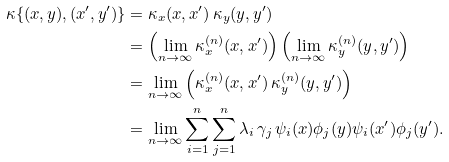Convert formula to latex. <formula><loc_0><loc_0><loc_500><loc_500>\kappa \{ ( x , y ) , ( x ^ { \prime } , y ^ { \prime } ) \} & = \kappa _ { x } ( x , x ^ { \prime } ) \, \kappa _ { y } ( y , y ^ { \prime } ) \\ & = \left ( \lim _ { n \to \infty } \kappa _ { x } ^ { ( n ) } ( x , x ^ { \prime } ) \right ) \left ( \lim _ { n \to \infty } \kappa _ { y } ^ { ( n ) } ( y , y ^ { \prime } ) \right ) \\ & = \lim _ { n \to \infty } \left ( \kappa _ { x } ^ { ( n ) } ( x , x ^ { \prime } ) \, \kappa _ { y } ^ { ( n ) } ( y , y ^ { \prime } ) \right ) \\ & = \lim _ { n \to \infty } \sum _ { i = 1 } ^ { n } \sum _ { j = 1 } ^ { n } \lambda _ { i } \, \gamma _ { j } \, \psi _ { i } ( x ) \phi _ { j } ( y ) \psi _ { i } ( x ^ { \prime } ) \phi _ { j } ( y ^ { \prime } ) .</formula> 